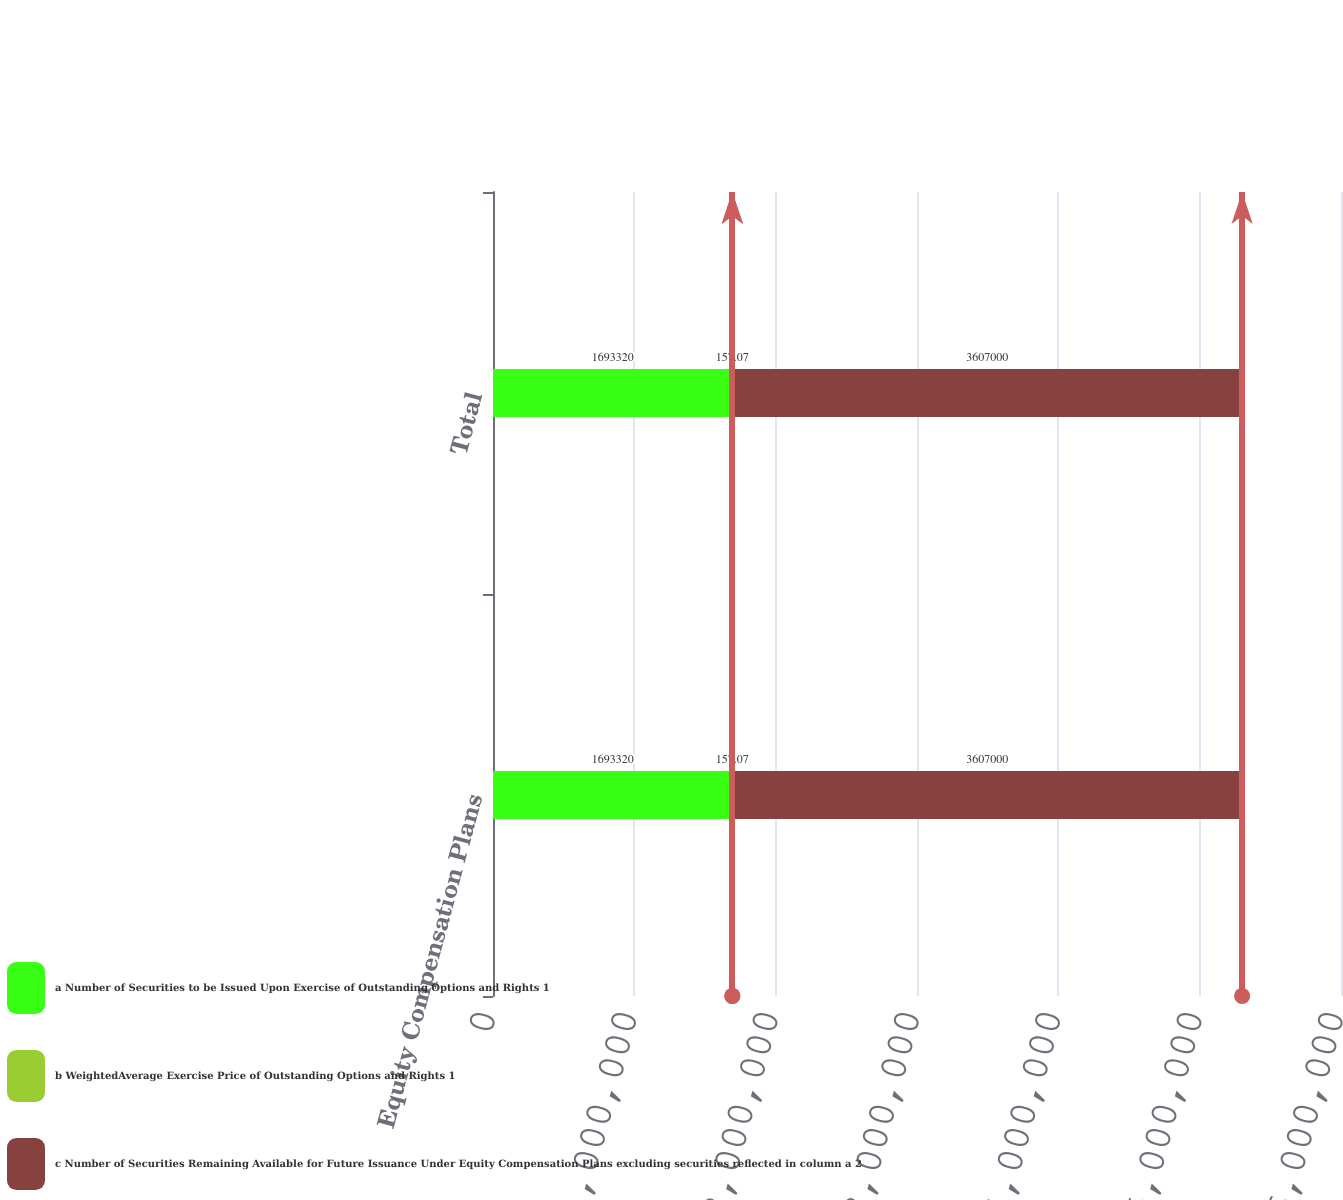Convert chart to OTSL. <chart><loc_0><loc_0><loc_500><loc_500><stacked_bar_chart><ecel><fcel>Equity Compensation Plans<fcel>Total<nl><fcel>a Number of Securities to be Issued Upon Exercise of Outstanding Options and Rights 1<fcel>1.69332e+06<fcel>1.69332e+06<nl><fcel>b WeightedAverage Exercise Price of Outstanding Options and Rights 1<fcel>157.07<fcel>157.07<nl><fcel>c Number of Securities Remaining Available for Future Issuance Under Equity Compensation Plans excluding securities reflected in column a 2<fcel>3.607e+06<fcel>3.607e+06<nl></chart> 